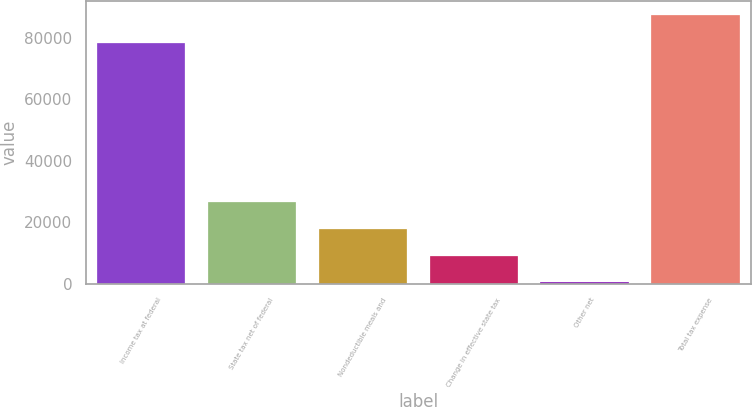Convert chart. <chart><loc_0><loc_0><loc_500><loc_500><bar_chart><fcel>Income tax at federal<fcel>State tax net of federal<fcel>Nondeductible meals and<fcel>Change in effective state tax<fcel>Other net<fcel>Total tax expense<nl><fcel>78424<fcel>26582.5<fcel>17861<fcel>9139.5<fcel>418<fcel>87633<nl></chart> 